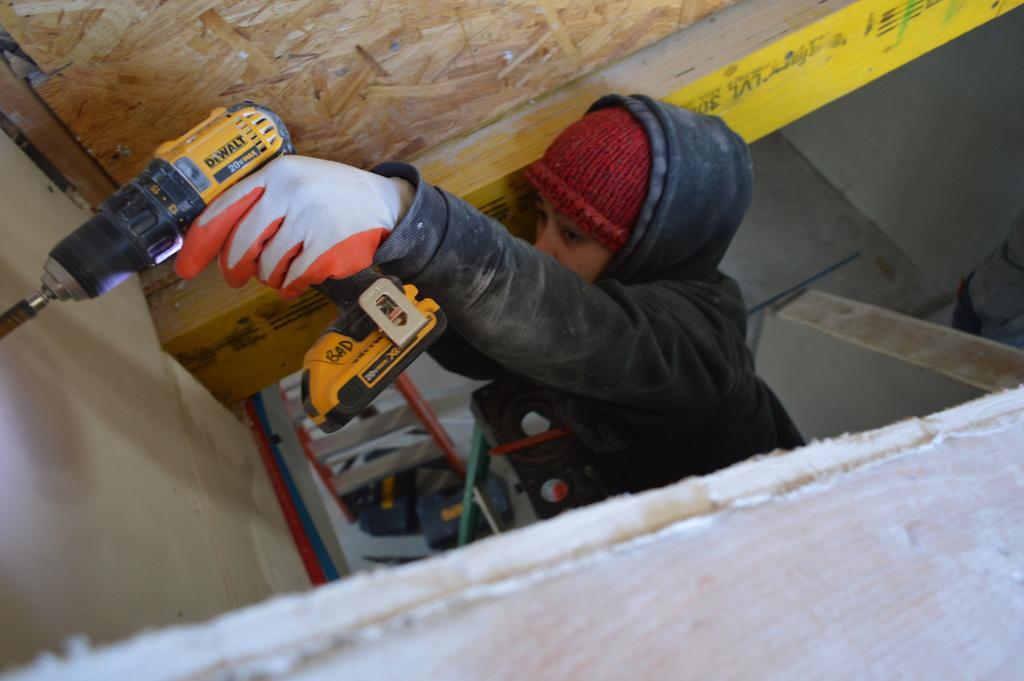Could you give a brief overview of what you see in this image? In this image we a person wearing black jacket and red color cap is holding a handheld power drill in their hands and drilling the surface. In the background, we can see the wooden wall. 